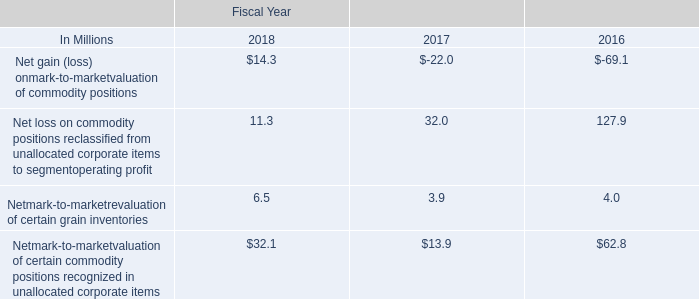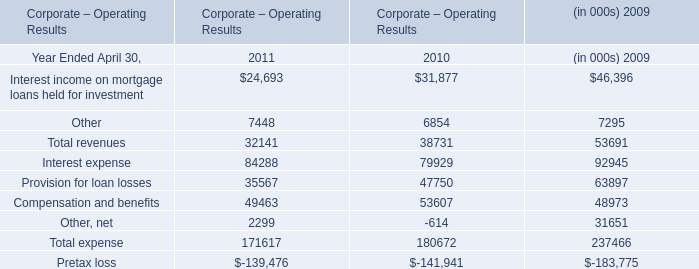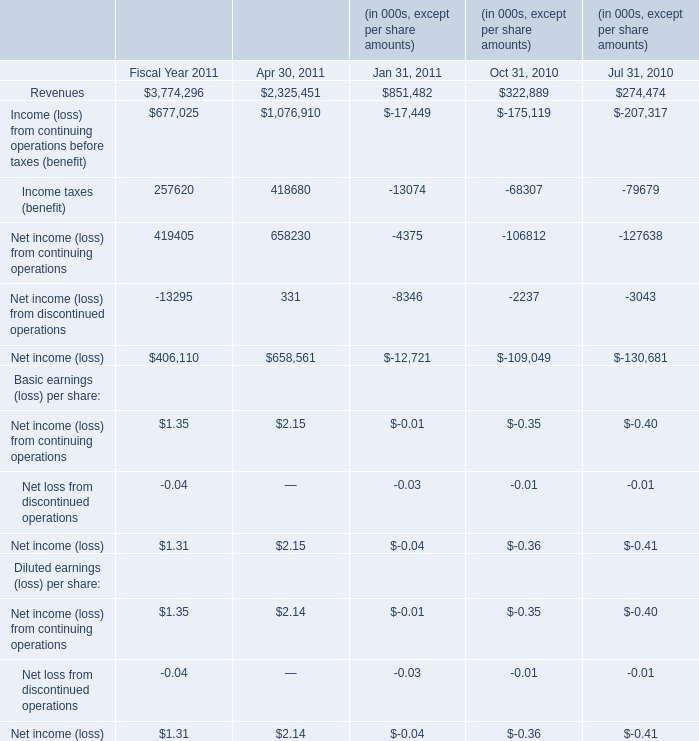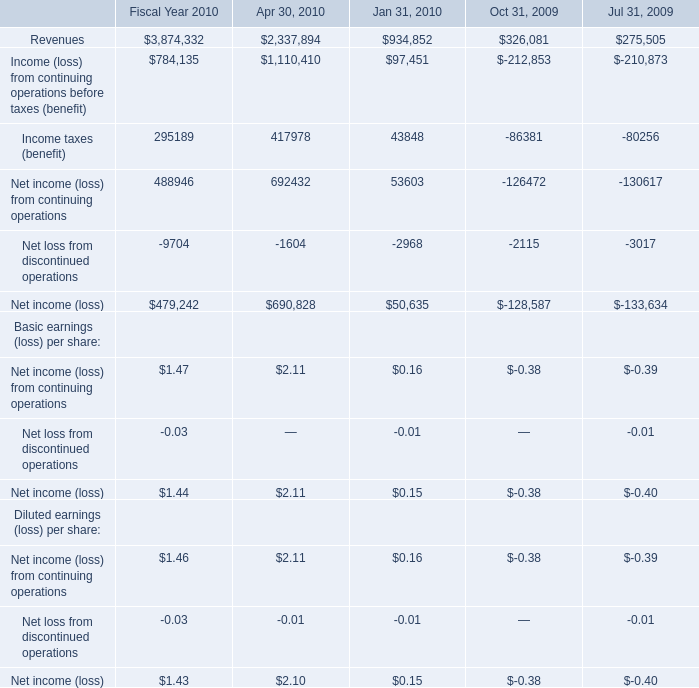What was the average value of Net income (loss) from discontinued operations, Net income (loss), Net income (loss) from continuing operations in 2011? (in thousand) 
Computations: (((((((((-13295 + 331) - 8346) + 406110) + 658561) - 12721) + 1.35) + 2.15) - 0.01) / 3)
Answer: 343547.83. 